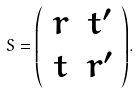<formula> <loc_0><loc_0><loc_500><loc_500>S = { \left ( \begin{array} { c c } r & t ^ { \prime } \\ t & r ^ { \prime } \\ \end{array} \right ) } .</formula> 